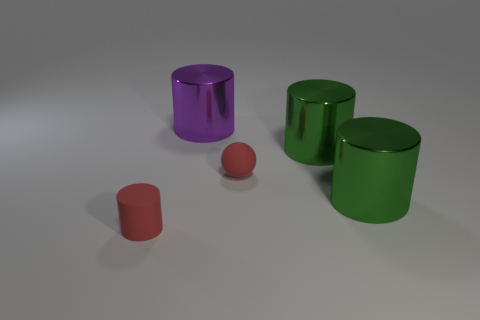Add 2 large purple shiny spheres. How many objects exist? 7 Subtract all purple metal cylinders. How many cylinders are left? 3 Subtract 0 yellow blocks. How many objects are left? 5 Subtract all cylinders. How many objects are left? 1 Subtract 4 cylinders. How many cylinders are left? 0 Subtract all purple cylinders. Subtract all brown spheres. How many cylinders are left? 3 Subtract all gray blocks. How many purple cylinders are left? 1 Subtract all small yellow shiny objects. Subtract all big purple things. How many objects are left? 4 Add 5 purple shiny cylinders. How many purple shiny cylinders are left? 6 Add 5 tiny green metal cylinders. How many tiny green metal cylinders exist? 5 